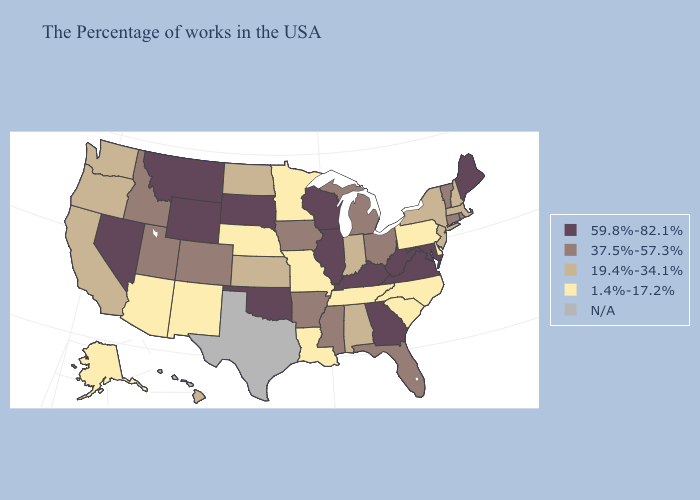What is the highest value in states that border Connecticut?
Keep it brief. 37.5%-57.3%. What is the value of Louisiana?
Answer briefly. 1.4%-17.2%. Name the states that have a value in the range 37.5%-57.3%?
Answer briefly. Rhode Island, Vermont, Connecticut, Ohio, Florida, Michigan, Mississippi, Arkansas, Iowa, Colorado, Utah, Idaho. Does Louisiana have the lowest value in the USA?
Short answer required. Yes. What is the value of Louisiana?
Give a very brief answer. 1.4%-17.2%. Does the first symbol in the legend represent the smallest category?
Quick response, please. No. Among the states that border Kansas , which have the highest value?
Be succinct. Oklahoma. Does South Carolina have the highest value in the South?
Be succinct. No. What is the highest value in the Northeast ?
Write a very short answer. 59.8%-82.1%. What is the value of Connecticut?
Short answer required. 37.5%-57.3%. What is the highest value in the USA?
Keep it brief. 59.8%-82.1%. Name the states that have a value in the range 37.5%-57.3%?
Give a very brief answer. Rhode Island, Vermont, Connecticut, Ohio, Florida, Michigan, Mississippi, Arkansas, Iowa, Colorado, Utah, Idaho. Name the states that have a value in the range N/A?
Concise answer only. Texas. 